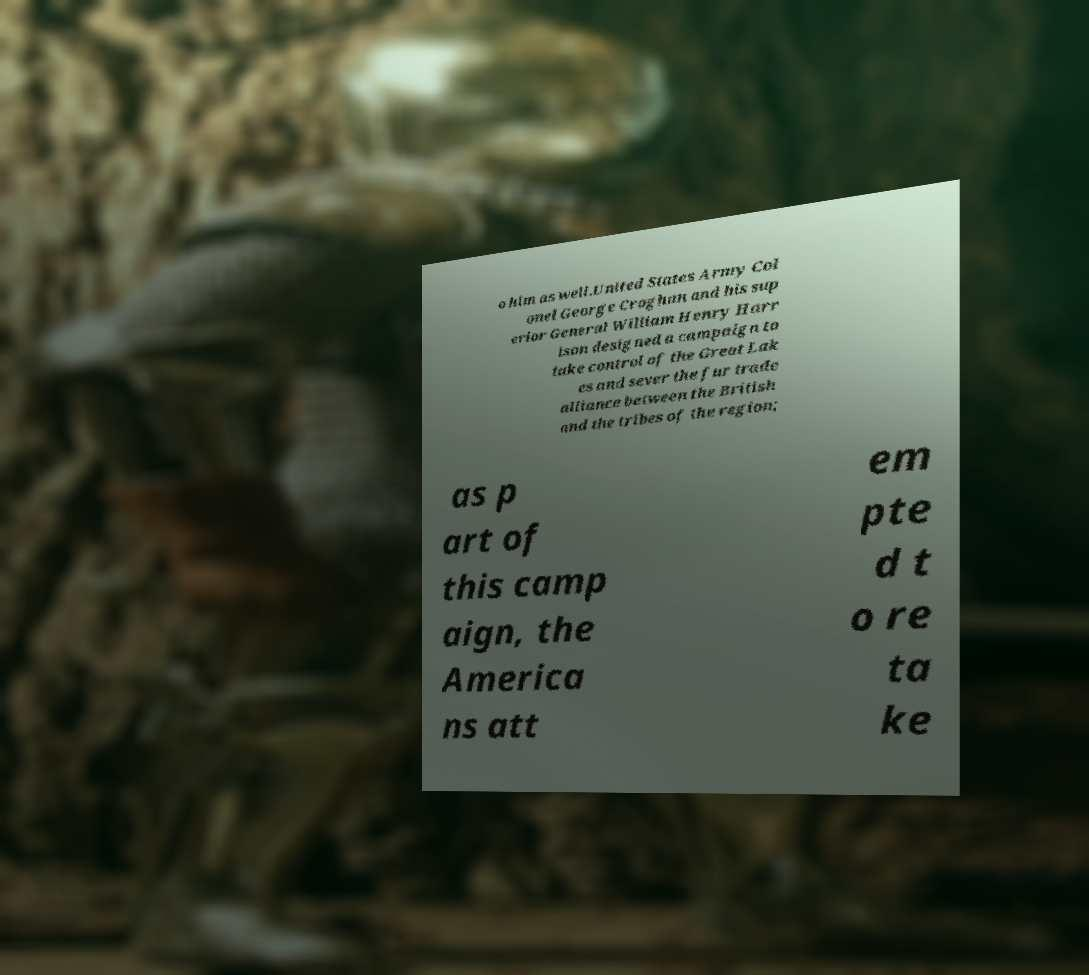Can you accurately transcribe the text from the provided image for me? o him as well.United States Army Col onel George Croghan and his sup erior General William Henry Harr ison designed a campaign to take control of the Great Lak es and sever the fur trade alliance between the British and the tribes of the region; as p art of this camp aign, the America ns att em pte d t o re ta ke 